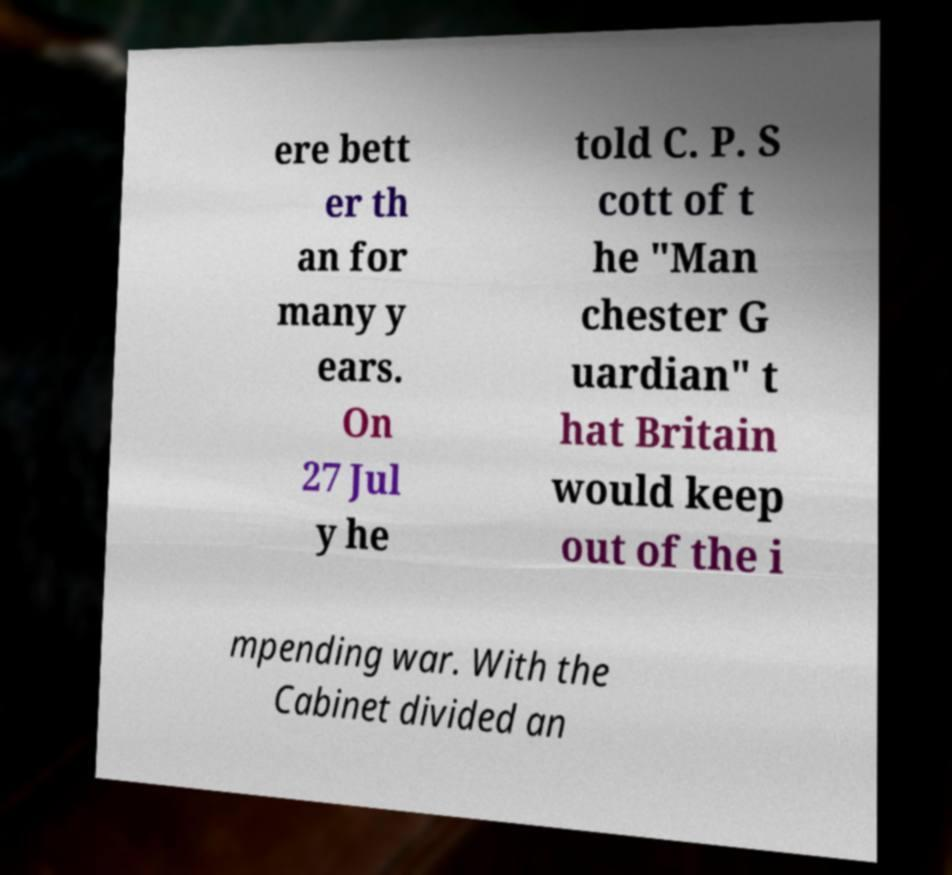Please read and relay the text visible in this image. What does it say? ere bett er th an for many y ears. On 27 Jul y he told C. P. S cott of t he "Man chester G uardian" t hat Britain would keep out of the i mpending war. With the Cabinet divided an 